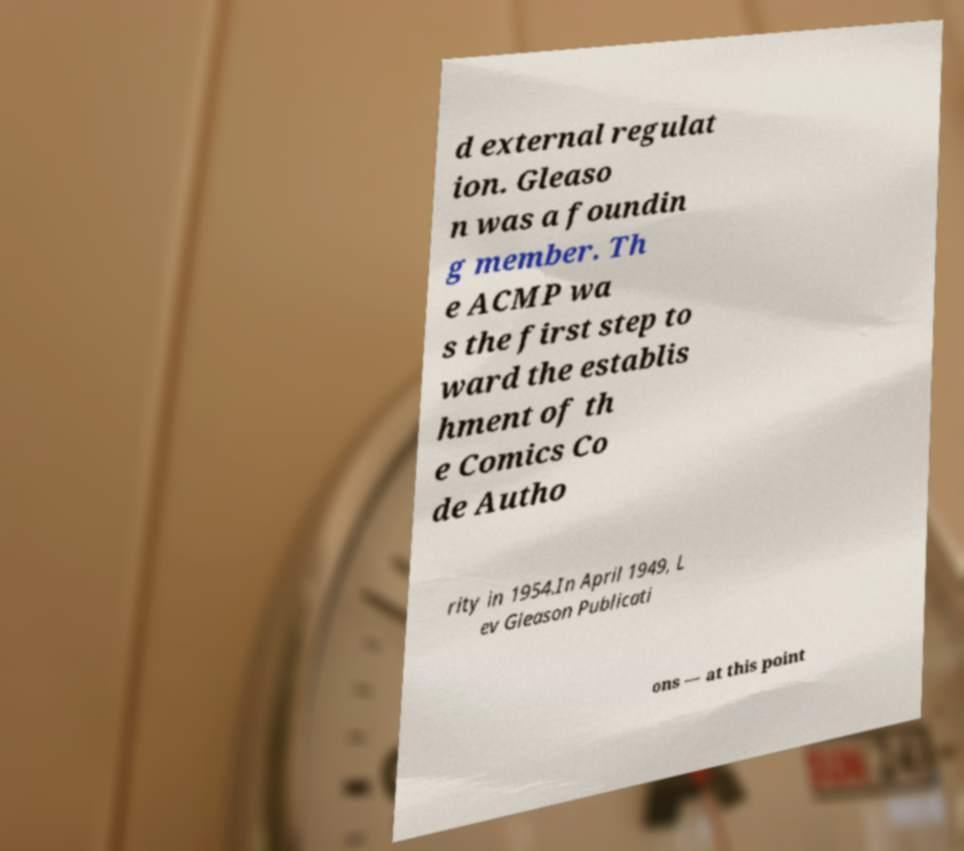What messages or text are displayed in this image? I need them in a readable, typed format. d external regulat ion. Gleaso n was a foundin g member. Th e ACMP wa s the first step to ward the establis hment of th e Comics Co de Autho rity in 1954.In April 1949, L ev Gleason Publicati ons — at this point 